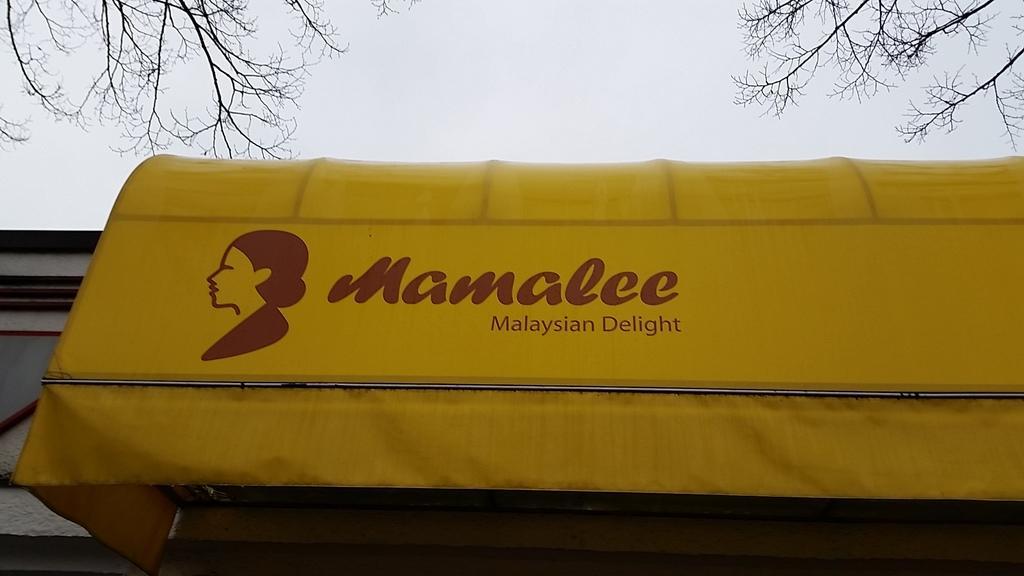Describe this image in one or two sentences. In this image we can see a banner on a wall with some text and picture on it. We can also see some branches of a tree and the sky. 